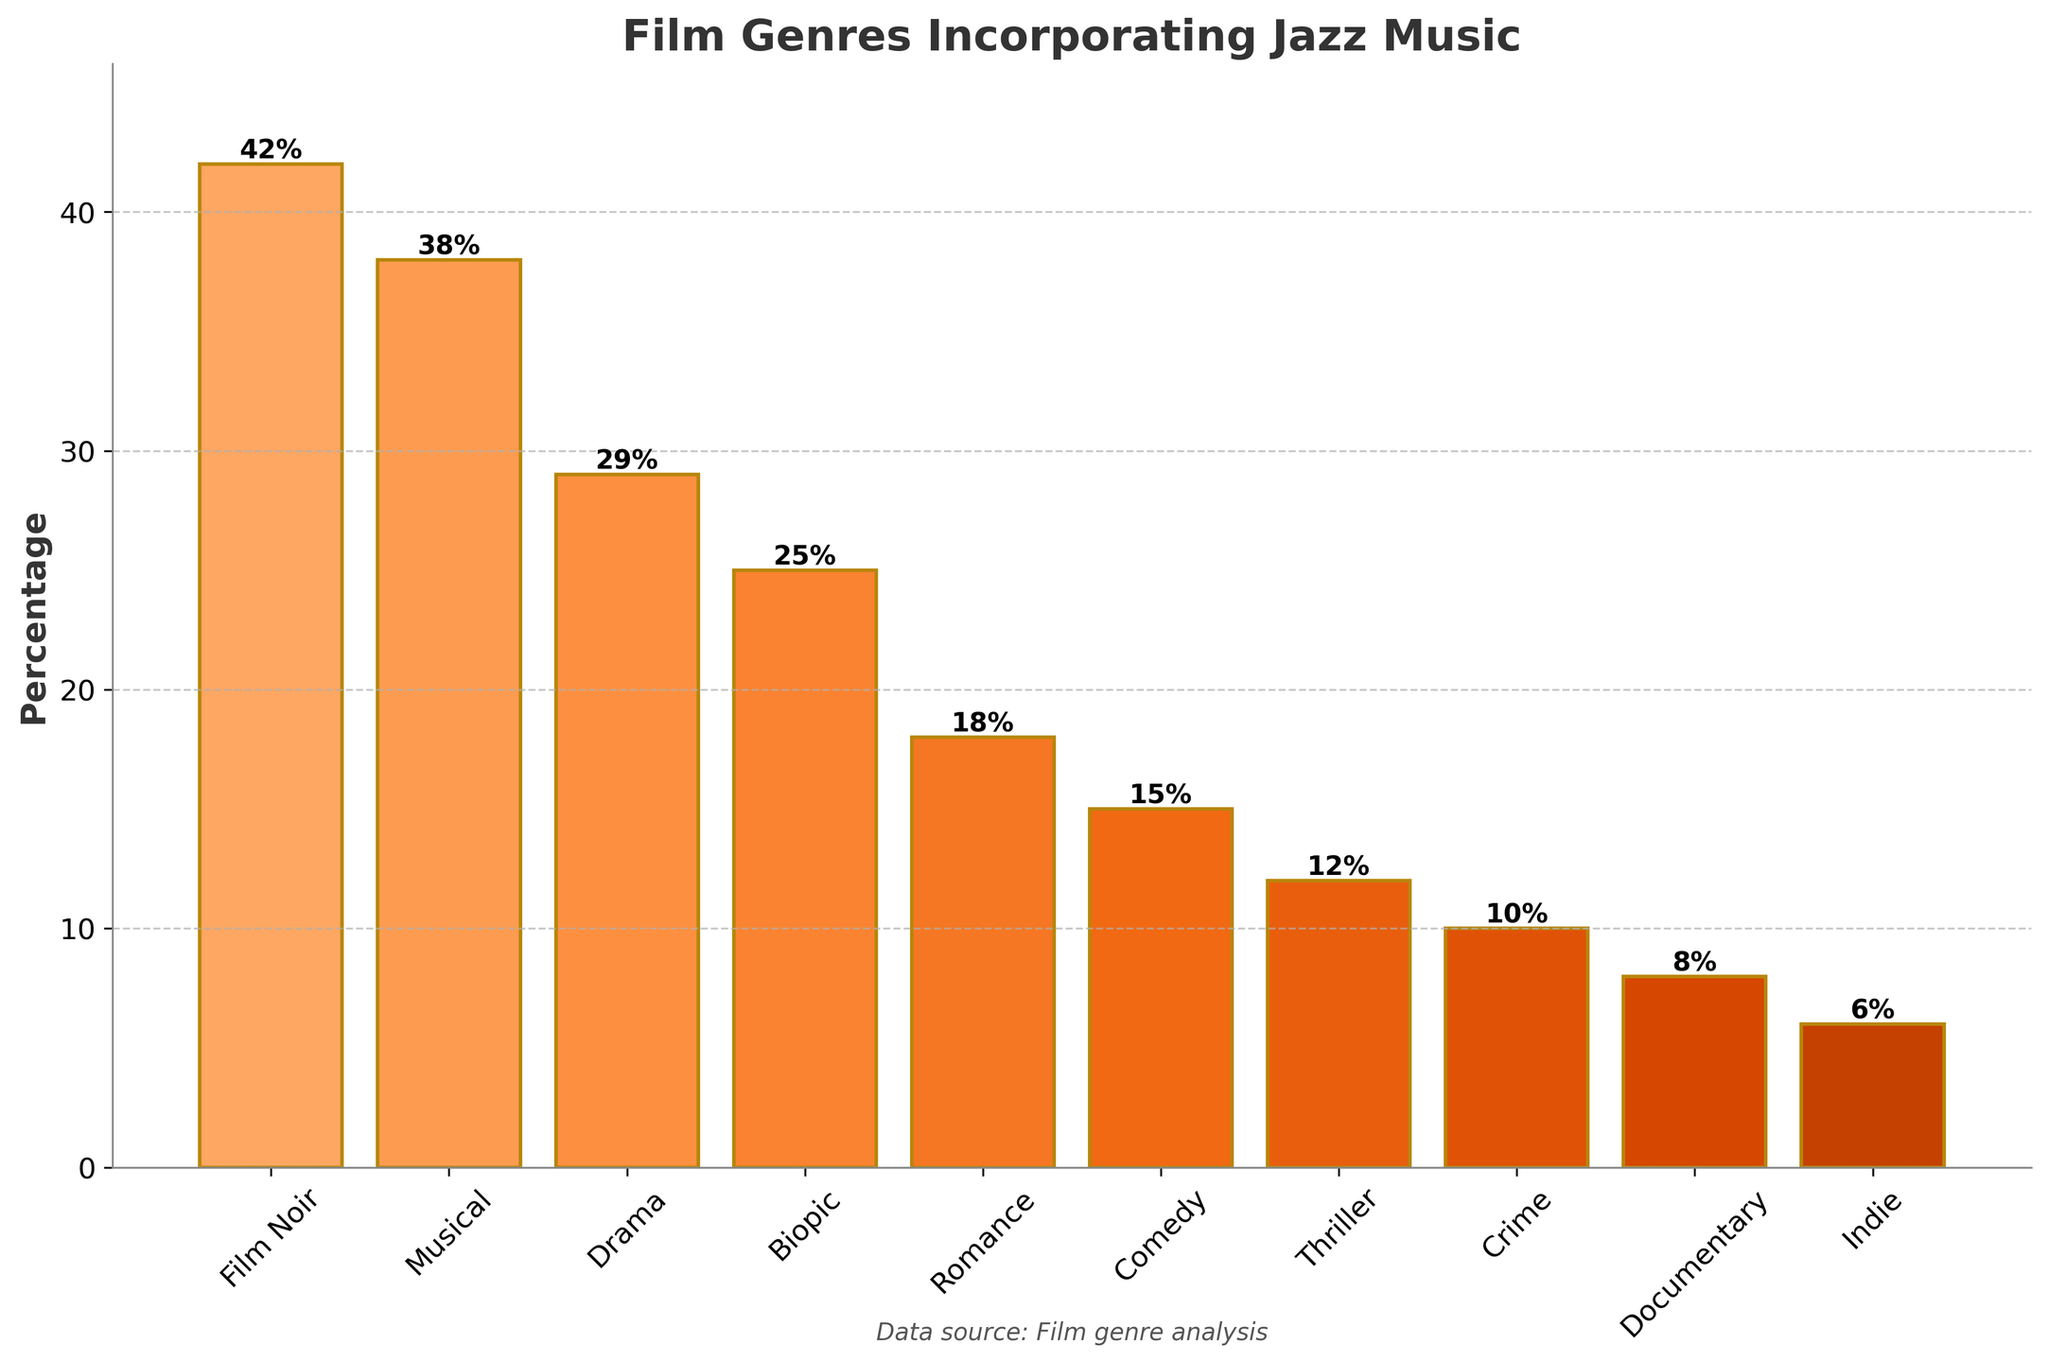Which film genre incorporates jazz music the most frequently? The genre with the highest percentage in the chart is the one that incorporates jazz music the most frequently. Based on the bar height, Film Noir is the genre with the highest percentage.
Answer: Film Noir Which has more frequent incorporation of jazz music: Romance or Crime? Compare the bar heights and percentages of Romance and Crime. The percentage for Romance is 18%, while for Crime it's 10%, making Romance higher.
Answer: Romance What is the difference in percentage between the genre with the highest and the genre with the lowest incorporation of jazz music? Identify the highest (Film Noir at 42%) and the lowest (Indie at 6%) percentages. Calculate the difference: 42% - 6% = 36%.
Answer: 36% How do Musical and Documentary genres compare in terms of jazz music incorporation? Compare the percentages: Musical is 38% and Documentary is 8%. Thus, Musical has a higher percentage than Documentary.
Answer: Musical What is the average percentage of jazz music incorporation across Drama, Biopic, and Comedy genres? Sum the percentages of Drama (29%), Biopic (25%), and Comedy (15%) and divide by 3. (29 + 25 + 15) / 3 = 23%.
Answer: 23% If you combine the percentages of Film Noir and Musical genres, what is the resultant percentage? Add the percentages of Film Noir (42%) and Musical (38%). 42% + 38% = 80%.
Answer: 80% Which two genres combined surpass the 50% threshold? Identify two genres whose combined percentages exceed 50%. For example, Musical (38%) and Drama (29%) combined total 67%, surpassing 50%.
Answer: Musical and Drama Order the top three genres in terms of jazz incorporation from highest to lowest. Identify the top three genres by their percentages: Film Noir (42%), Musical (38%), and Drama (29%). Order from highest to lowest: Film Noir, Musical, Drama.
Answer: Film Noir, Musical, Drama What is the total percentage of jazz music incorporation for genres below 20%? Sum the percentages of Romance (18%), Comedy (15%), Thriller (12%), Crime (10%), Documentary (8%), and Indie (6%). 18 + 15 + 12 + 10 + 8 + 6 = 69%.
Answer: 69% Which two genres have an equal difference in their percentage of jazz music incorporation? Look for pairs of genres that have the same difference in their percentages. For example, Romance (18%) and Comedy (15%) have a difference of 3%, and Thriller (12%) and Crime (10%) also have a difference of 2%.
Answer: Romance and Comedy plus Thriller and Crime 